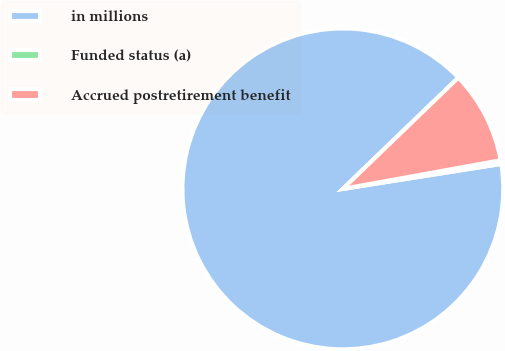<chart> <loc_0><loc_0><loc_500><loc_500><pie_chart><fcel>in millions<fcel>Funded status (a)<fcel>Accrued postretirement benefit<nl><fcel>90.29%<fcel>0.36%<fcel>9.35%<nl></chart> 